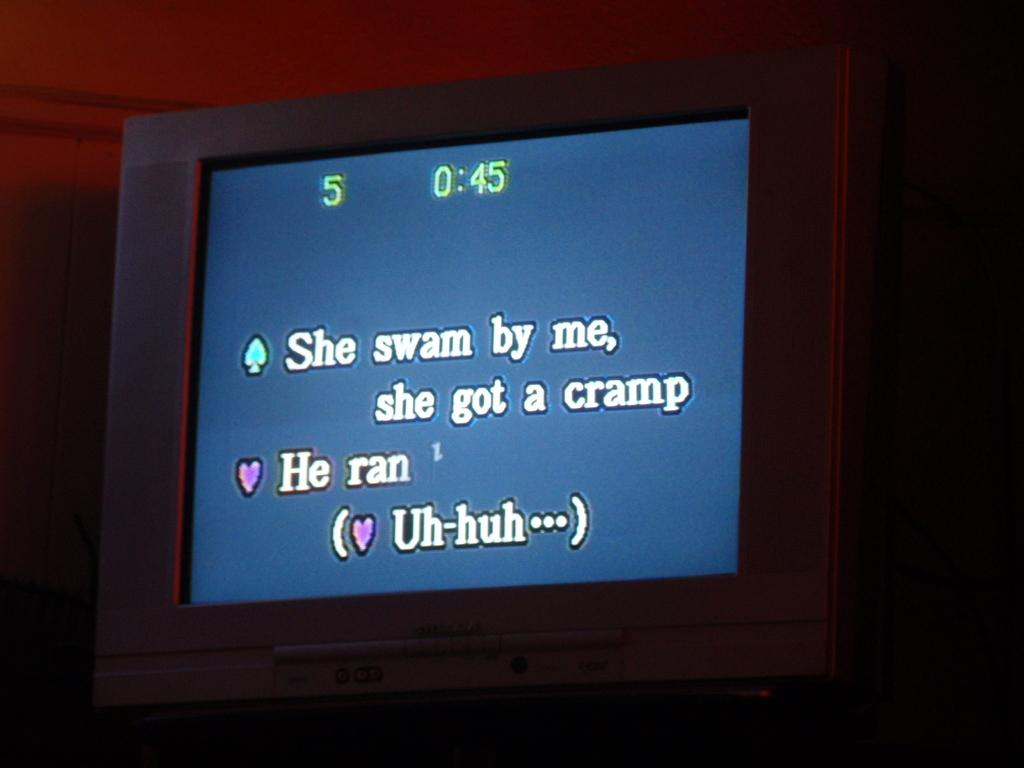<image>
Summarize the visual content of the image. A television screen that read she swam by me she got a cramp. 